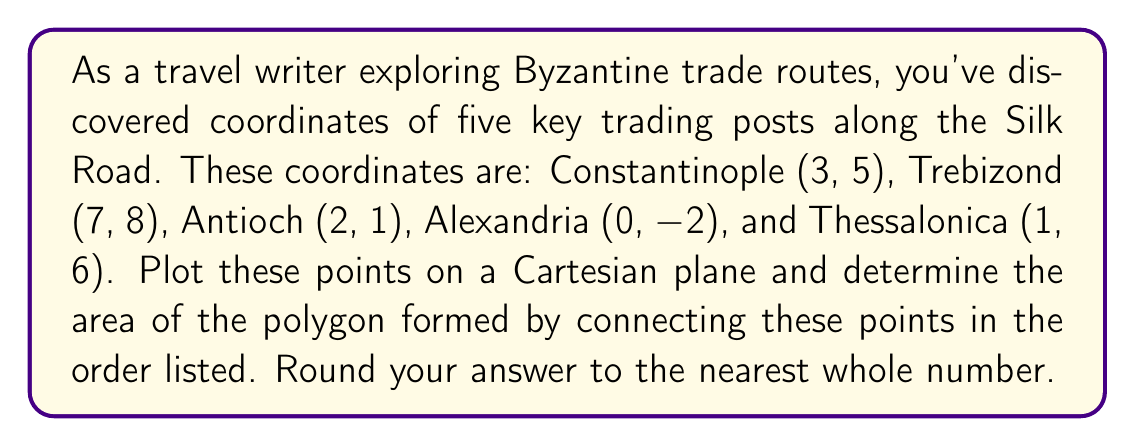Provide a solution to this math problem. To solve this problem, we'll follow these steps:

1) Plot the points on a Cartesian plane:
   Constantinople (3, 5)
   Trebizond (7, 8)
   Antioch (2, 1)
   Alexandria (0, -2)
   Thessalonica (1, 6)

2) Connect these points in the order given to form a polygon.

3) Calculate the area of this polygon using the Shoelace formula (also known as the surveyor's formula).

The Shoelace formula for a polygon with vertices $(x_1, y_1), (x_2, y_2), ..., (x_n, y_n)$ is:

$$ \text{Area} = \frac{1}{2}|(x_1y_2 + x_2y_3 + ... + x_ny_1) - (y_1x_2 + y_2x_3 + ... + y_nx_1)| $$

4) Applying the formula to our points:

$$ \begin{align*}
\text{Area} &= \frac{1}{2}|(3 \cdot 8 + 7 \cdot 1 + 2 \cdot (-2) + 0 \cdot 6 + 1 \cdot 5) \\
&- (5 \cdot 7 + 8 \cdot 2 + 1 \cdot 0 + (-2) \cdot 1 + 6 \cdot 3)|
\end{align*} $$

$$ = \frac{1}{2}|(24 + 7 - 4 + 0 + 5) - (35 + 16 + 0 - 2 + 18)| $$

$$ = \frac{1}{2}|32 - 67| = \frac{1}{2} \cdot 35 = 17.5 $$

5) Rounding to the nearest whole number: 18
Answer: 18 square units 